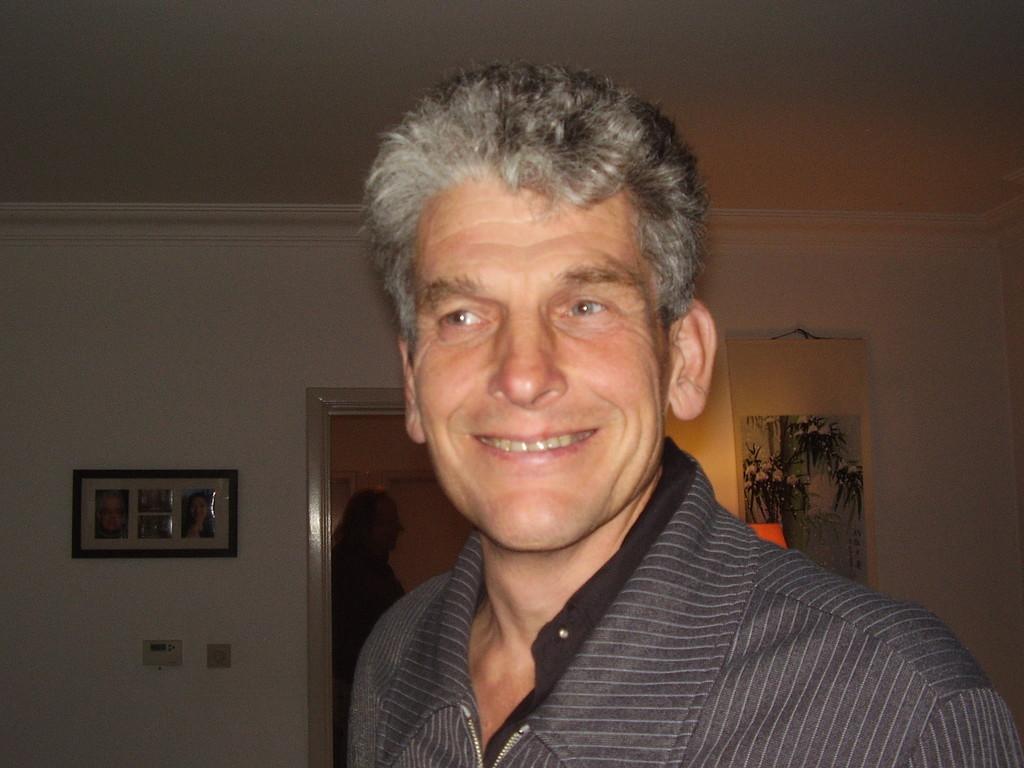In one or two sentences, can you explain what this image depicts? In this image I can see a man and I can see smile on his face. In the background I can see few frames on wall. 